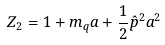Convert formula to latex. <formula><loc_0><loc_0><loc_500><loc_500>Z _ { 2 } = 1 + m _ { q } a + \frac { 1 } { 2 } \hat { p } ^ { 2 } a ^ { 2 }</formula> 